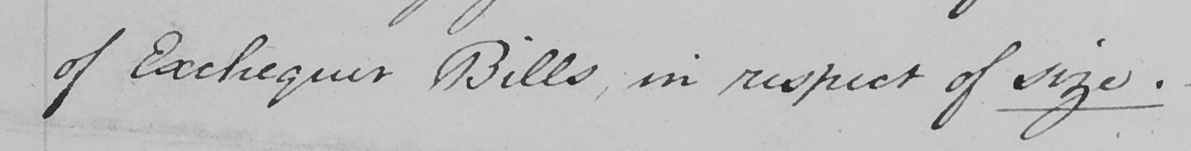Please transcribe the handwritten text in this image. of Exchequer Bills , in respect of size .  _ 